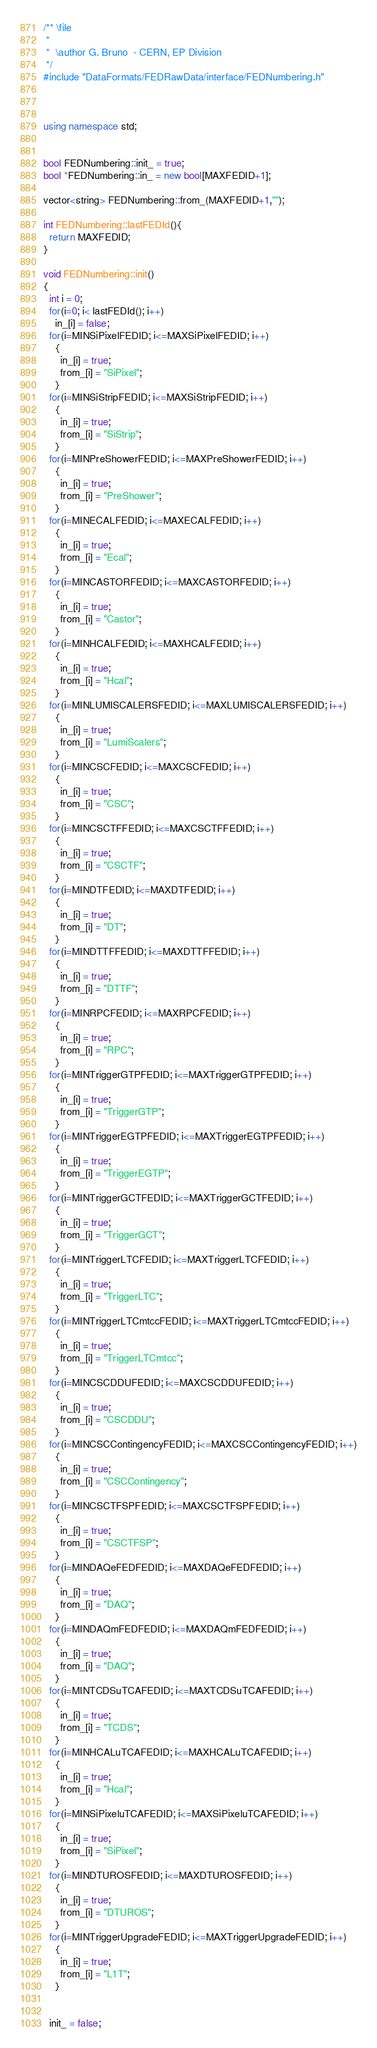<code> <loc_0><loc_0><loc_500><loc_500><_C++_>/** \file
 *
 *  \author G. Bruno  - CERN, EP Division
 */
#include "DataFormats/FEDRawData/interface/FEDNumbering.h"



using namespace std;


bool FEDNumbering::init_ = true;
bool *FEDNumbering::in_ = new bool[MAXFEDID+1];

vector<string> FEDNumbering::from_(MAXFEDID+1,"");

int FEDNumbering::lastFEDId(){
  return MAXFEDID;
}

void FEDNumbering::init()
{
  int i = 0;
  for(i=0; i< lastFEDId(); i++)
    in_[i] = false;
  for(i=MINSiPixelFEDID; i<=MAXSiPixelFEDID; i++)
    {
      in_[i] = true;
      from_[i] = "SiPixel";
    }
  for(i=MINSiStripFEDID; i<=MAXSiStripFEDID; i++)
    {
      in_[i] = true;
      from_[i] = "SiStrip";
    }
  for(i=MINPreShowerFEDID; i<=MAXPreShowerFEDID; i++)
    {
      in_[i] = true;
      from_[i] = "PreShower";
    }
  for(i=MINECALFEDID; i<=MAXECALFEDID; i++)
    {
      in_[i] = true;
      from_[i] = "Ecal";
    }
  for(i=MINCASTORFEDID; i<=MAXCASTORFEDID; i++)
    {
      in_[i] = true;
      from_[i] = "Castor";
    }
  for(i=MINHCALFEDID; i<=MAXHCALFEDID; i++)
    {
      in_[i] = true;
      from_[i] = "Hcal";
    }
  for(i=MINLUMISCALERSFEDID; i<=MAXLUMISCALERSFEDID; i++)
    {
      in_[i] = true;
      from_[i] = "LumiScalers";
    }
  for(i=MINCSCFEDID; i<=MAXCSCFEDID; i++)
    {
      in_[i] = true;
      from_[i] = "CSC";
    }
  for(i=MINCSCTFFEDID; i<=MAXCSCTFFEDID; i++)
    {
      in_[i] = true;
      from_[i] = "CSCTF";
    }
  for(i=MINDTFEDID; i<=MAXDTFEDID; i++)
    {
      in_[i] = true;
      from_[i] = "DT";
    }
  for(i=MINDTTFFEDID; i<=MAXDTTFFEDID; i++)
    {
      in_[i] = true;
      from_[i] = "DTTF";
    }
  for(i=MINRPCFEDID; i<=MAXRPCFEDID; i++)
    {
      in_[i] = true;
      from_[i] = "RPC";
    }
  for(i=MINTriggerGTPFEDID; i<=MAXTriggerGTPFEDID; i++)
    {
      in_[i] = true;
      from_[i] = "TriggerGTP";
    }
  for(i=MINTriggerEGTPFEDID; i<=MAXTriggerEGTPFEDID; i++)
    {
      in_[i] = true;
      from_[i] = "TriggerEGTP";
    }
  for(i=MINTriggerGCTFEDID; i<=MAXTriggerGCTFEDID; i++)
    {
      in_[i] = true;
      from_[i] = "TriggerGCT";
    }
  for(i=MINTriggerLTCFEDID; i<=MAXTriggerLTCFEDID; i++)
    {
      in_[i] = true;
      from_[i] = "TriggerLTC";
    }
  for(i=MINTriggerLTCmtccFEDID; i<=MAXTriggerLTCmtccFEDID; i++)
    {
      in_[i] = true;
      from_[i] = "TriggerLTCmtcc";
    }
  for(i=MINCSCDDUFEDID; i<=MAXCSCDDUFEDID; i++)
    {
      in_[i] = true;
      from_[i] = "CSCDDU";
    }
  for(i=MINCSCContingencyFEDID; i<=MAXCSCContingencyFEDID; i++)
    {
      in_[i] = true;
      from_[i] = "CSCContingency";
    }
  for(i=MINCSCTFSPFEDID; i<=MAXCSCTFSPFEDID; i++)
    {
      in_[i] = true;
      from_[i] = "CSCTFSP";
    }
  for(i=MINDAQeFEDFEDID; i<=MAXDAQeFEDFEDID; i++)
    {
      in_[i] = true;
      from_[i] = "DAQ";
    }
  for(i=MINDAQmFEDFEDID; i<=MAXDAQmFEDFEDID; i++)
    {
      in_[i] = true;
      from_[i] = "DAQ";
    }
  for(i=MINTCDSuTCAFEDID; i<=MAXTCDSuTCAFEDID; i++)
    {
      in_[i] = true;
      from_[i] = "TCDS";
    }
  for(i=MINHCALuTCAFEDID; i<=MAXHCALuTCAFEDID; i++)
    {
      in_[i] = true;
      from_[i] = "Hcal";
    }
  for(i=MINSiPixeluTCAFEDID; i<=MAXSiPixeluTCAFEDID; i++)
    {
      in_[i] = true;
      from_[i] = "SiPixel";
    }
  for(i=MINDTUROSFEDID; i<=MAXDTUROSFEDID; i++)
    {
      in_[i] = true;
      from_[i] = "DTUROS";
    }
  for(i=MINTriggerUpgradeFEDID; i<=MAXTriggerUpgradeFEDID; i++)
    {
      in_[i] = true;
      from_[i] = "L1T";
    }


  init_ = false;</code> 